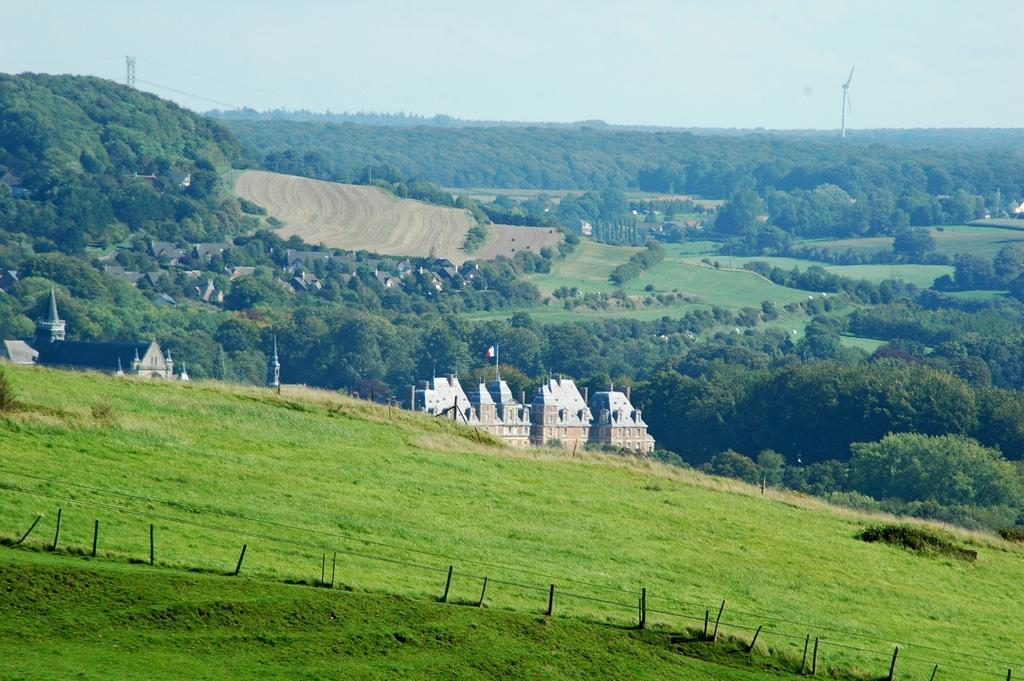What type of vegetation is in the foreground of the image? There is grass in the foreground of the image. What structures can be seen in the middle of the image? There are houses and trees in the middle of the image. Are there any trees visible in the background of the image? Yes, there are trees in the background of the image. What type of arithmetic problem is being solved on the shirt in the image? There is no shirt or arithmetic problem present in the image. How is the knot tied on the tree in the image? There is no knot on any tree in the image. 